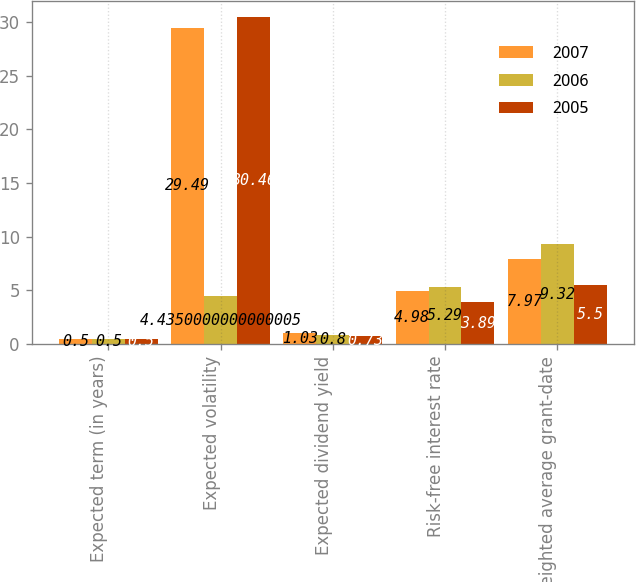<chart> <loc_0><loc_0><loc_500><loc_500><stacked_bar_chart><ecel><fcel>Expected term (in years)<fcel>Expected volatility<fcel>Expected dividend yield<fcel>Risk-free interest rate<fcel>Weighted average grant-date<nl><fcel>2007<fcel>0.5<fcel>29.49<fcel>1.03<fcel>4.98<fcel>7.97<nl><fcel>2006<fcel>0.5<fcel>4.435<fcel>0.8<fcel>5.29<fcel>9.32<nl><fcel>2005<fcel>0.5<fcel>30.46<fcel>0.73<fcel>3.89<fcel>5.5<nl></chart> 